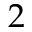Convert formula to latex. <formula><loc_0><loc_0><loc_500><loc_500>2</formula> 